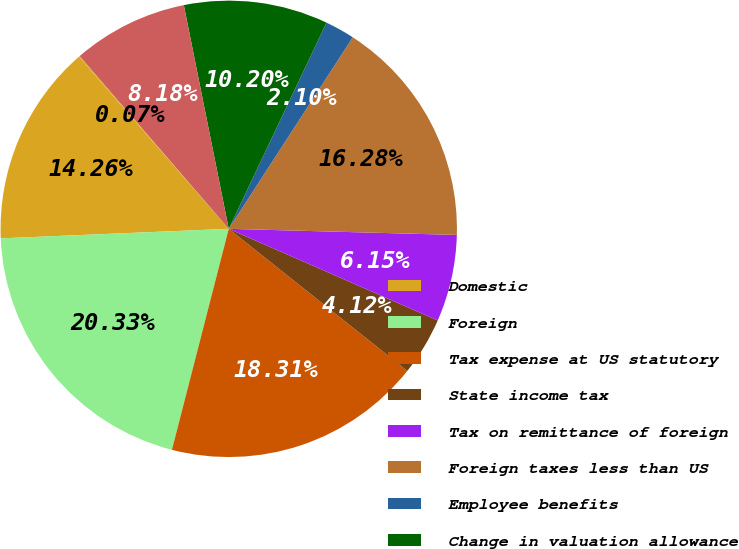Convert chart. <chart><loc_0><loc_0><loc_500><loc_500><pie_chart><fcel>Domestic<fcel>Foreign<fcel>Tax expense at US statutory<fcel>State income tax<fcel>Tax on remittance of foreign<fcel>Foreign taxes less than US<fcel>Employee benefits<fcel>Change in valuation allowance<fcel>Release of unrecognized tax<fcel>Other net<nl><fcel>14.26%<fcel>20.33%<fcel>18.31%<fcel>4.12%<fcel>6.15%<fcel>16.28%<fcel>2.1%<fcel>10.2%<fcel>8.18%<fcel>0.07%<nl></chart> 